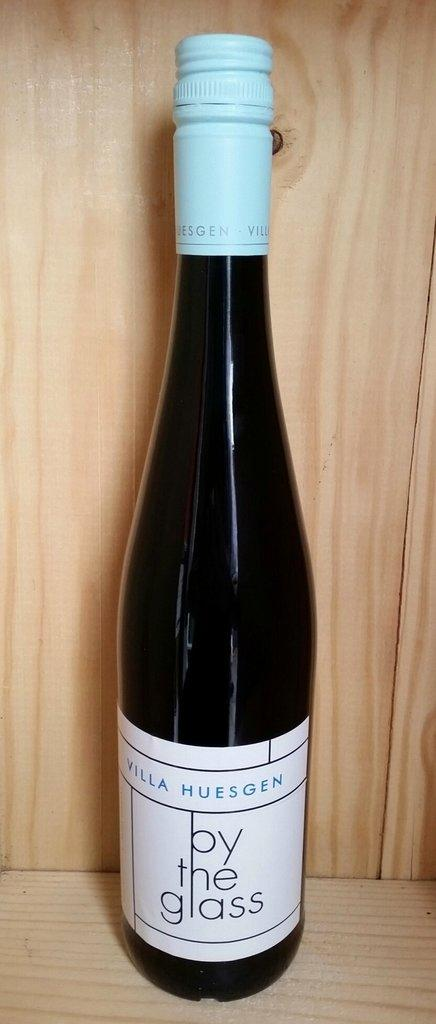<image>
Offer a succinct explanation of the picture presented. A bottle of Villa Huesgen by the glass wine is on a wooden shelf. 